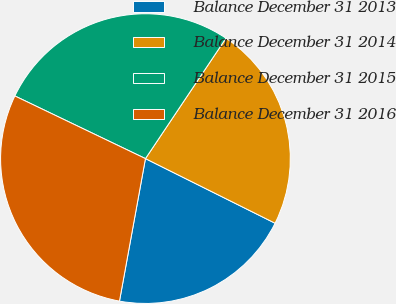<chart> <loc_0><loc_0><loc_500><loc_500><pie_chart><fcel>Balance December 31 2013<fcel>Balance December 31 2014<fcel>Balance December 31 2015<fcel>Balance December 31 2016<nl><fcel>20.51%<fcel>22.98%<fcel>27.26%<fcel>29.25%<nl></chart> 